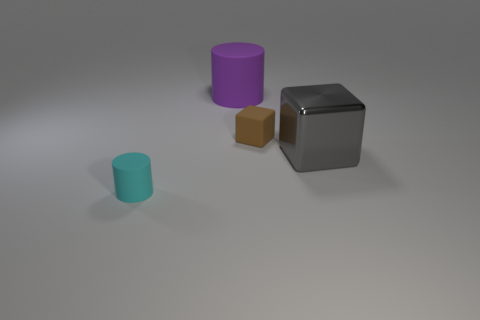Can you tell me what materials the objects in the image might be made of? The purple and teal cylinders appear to have a matte finish indicative of plastic, while the brown cube might be made of wood, given its texture and color. The grey cube has a reflective surface that suggests it could be made of metal. 